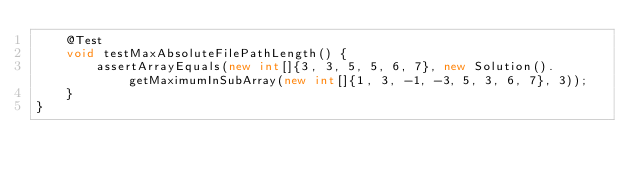<code> <loc_0><loc_0><loc_500><loc_500><_Java_>    @Test
    void testMaxAbsoluteFilePathLength() {
        assertArrayEquals(new int[]{3, 3, 5, 5, 6, 7}, new Solution().getMaximumInSubArray(new int[]{1, 3, -1, -3, 5, 3, 6, 7}, 3));
    }
}
</code> 